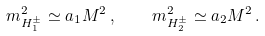<formula> <loc_0><loc_0><loc_500><loc_500>m _ { H _ { 1 } ^ { \pm } } ^ { 2 } \simeq a _ { 1 } M ^ { 2 } \, , \quad m _ { H _ { 2 } ^ { \pm } } ^ { 2 } \simeq a _ { 2 } M ^ { 2 } \, .</formula> 